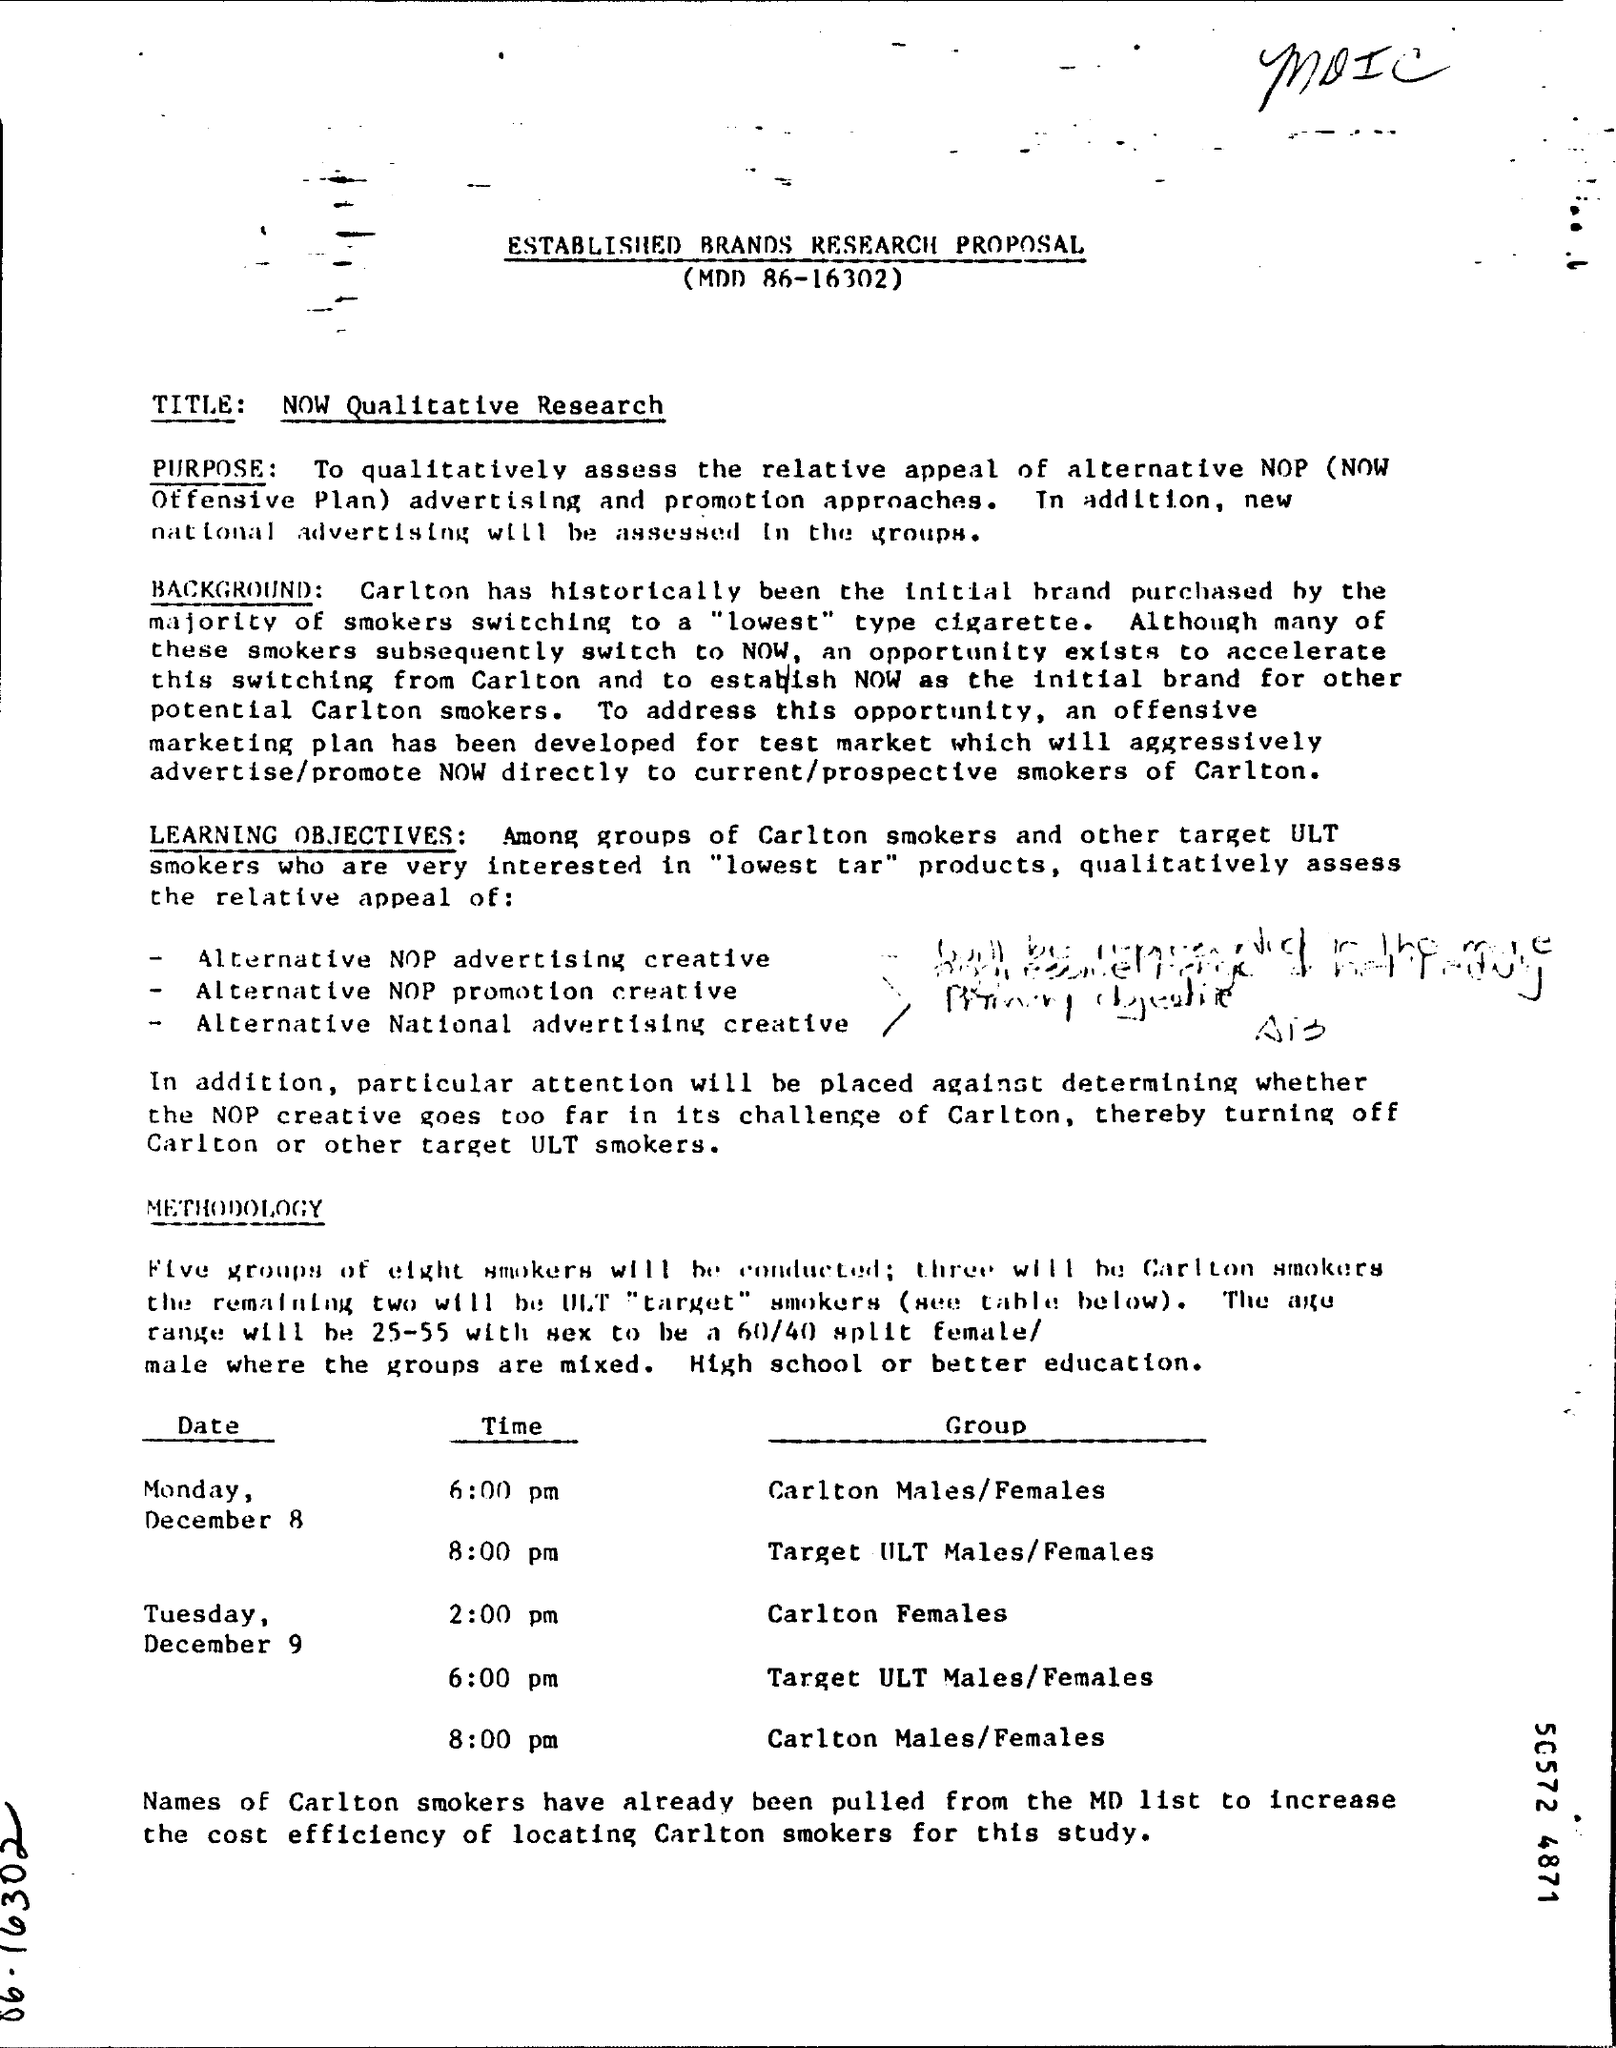What does NOP stand for ?
Make the answer very short. NOW Offensive Plan. What has been the initial brand purchased by the majority of smokers switching to a "lowest" type of cigarette ?
Your answer should be very brief. Carlton. Out of the five, how many groups will be Carlton?
Offer a terse response. Three. What is the 'title' of the research ?
Your response must be concise. NOW Qualitative research. 